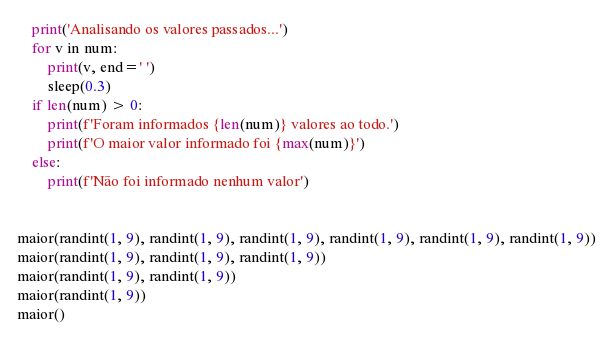<code> <loc_0><loc_0><loc_500><loc_500><_Python_>    print('Analisando os valores passados...')
    for v in num:
        print(v, end=' ')
        sleep(0.3)
    if len(num) > 0:
        print(f'Foram informados {len(num)} valores ao todo.')
        print(f'O maior valor informado foi {max(num)}')
    else:
        print(f'Não foi informado nenhum valor')


maior(randint(1, 9), randint(1, 9), randint(1, 9), randint(1, 9), randint(1, 9), randint(1, 9))
maior(randint(1, 9), randint(1, 9), randint(1, 9))
maior(randint(1, 9), randint(1, 9))
maior(randint(1, 9))
maior()
</code> 